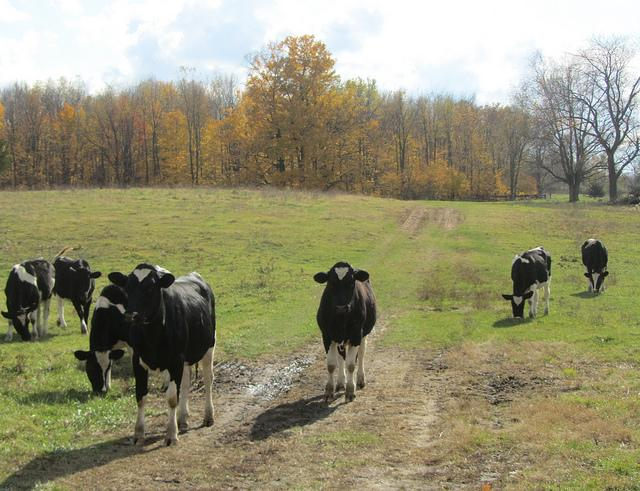What likely made the tracks on the ground?

Choices:
A) plane
B) skis
C) cows
D) truck truck 